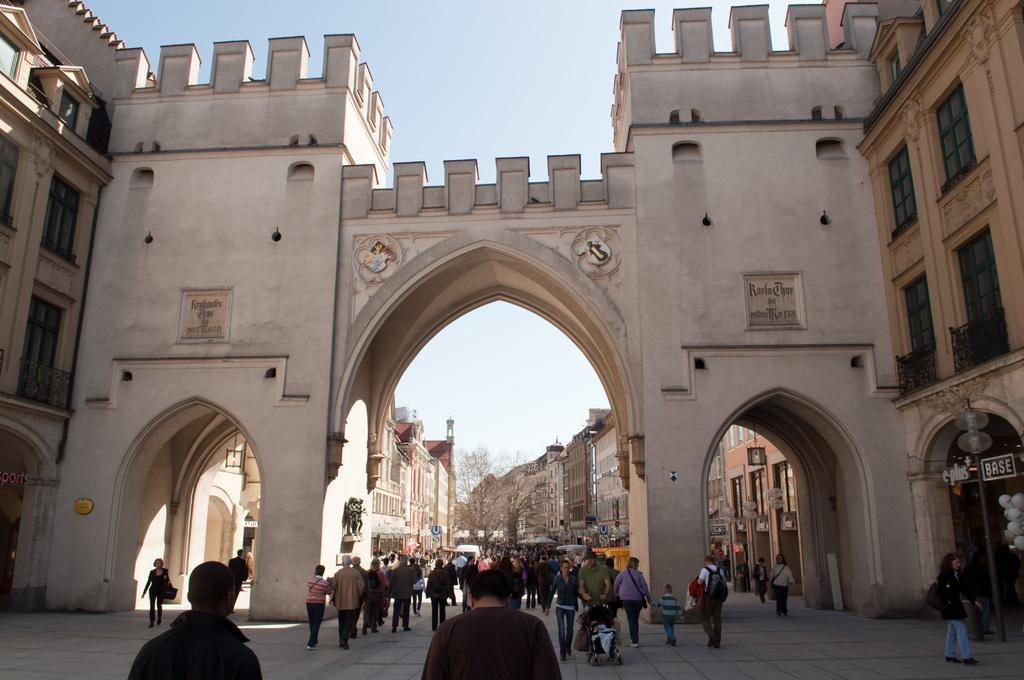What are the people in the image doing? The people in the image are walking on the floor. What can be seen in the background of the image? There are buildings, trees, and light poles in the background of the image. What is visible at the top of the image? The sky is visible at the top of the image. What direction are the kittens facing in the image? There are no kittens present in the image. What type of agreement was reached by the people in the image? There is no indication of any agreement being reached in the image, as it only shows people walking on the floor. 